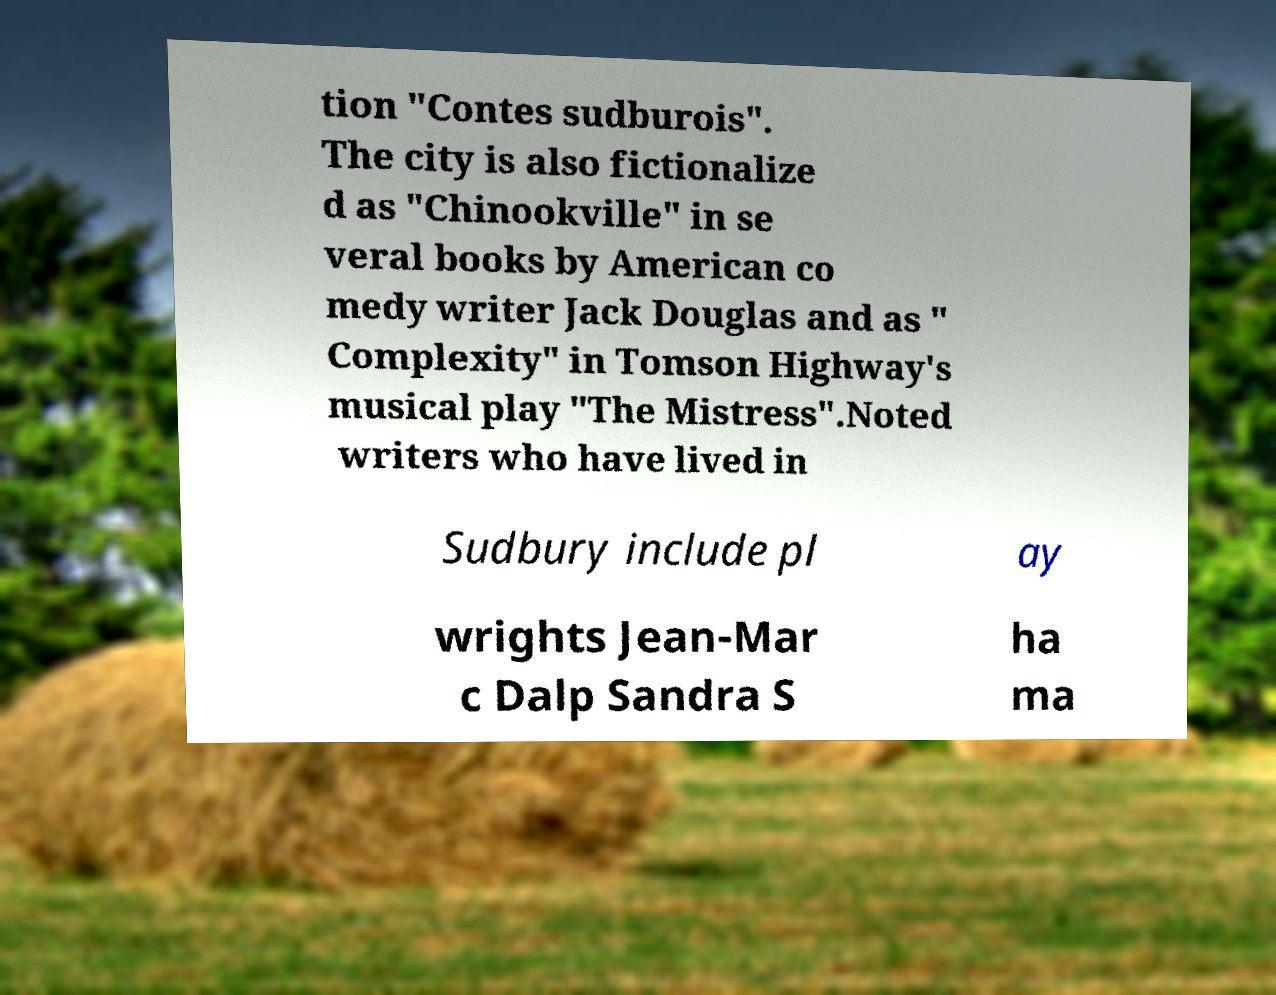I need the written content from this picture converted into text. Can you do that? tion "Contes sudburois". The city is also fictionalize d as "Chinookville" in se veral books by American co medy writer Jack Douglas and as " Complexity" in Tomson Highway's musical play "The Mistress".Noted writers who have lived in Sudbury include pl ay wrights Jean-Mar c Dalp Sandra S ha ma 